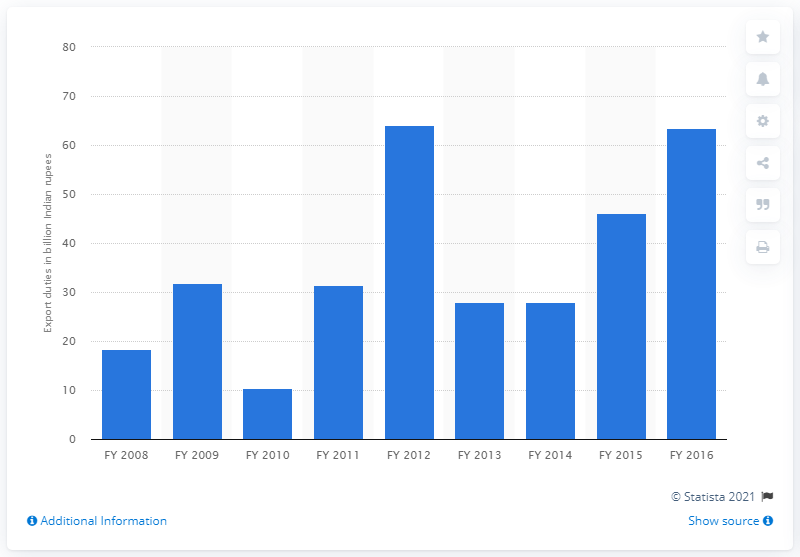Highlight a few significant elements in this photo. In financial year 2016, the Indian government earned 63.46 Indian rupees from export duties. 